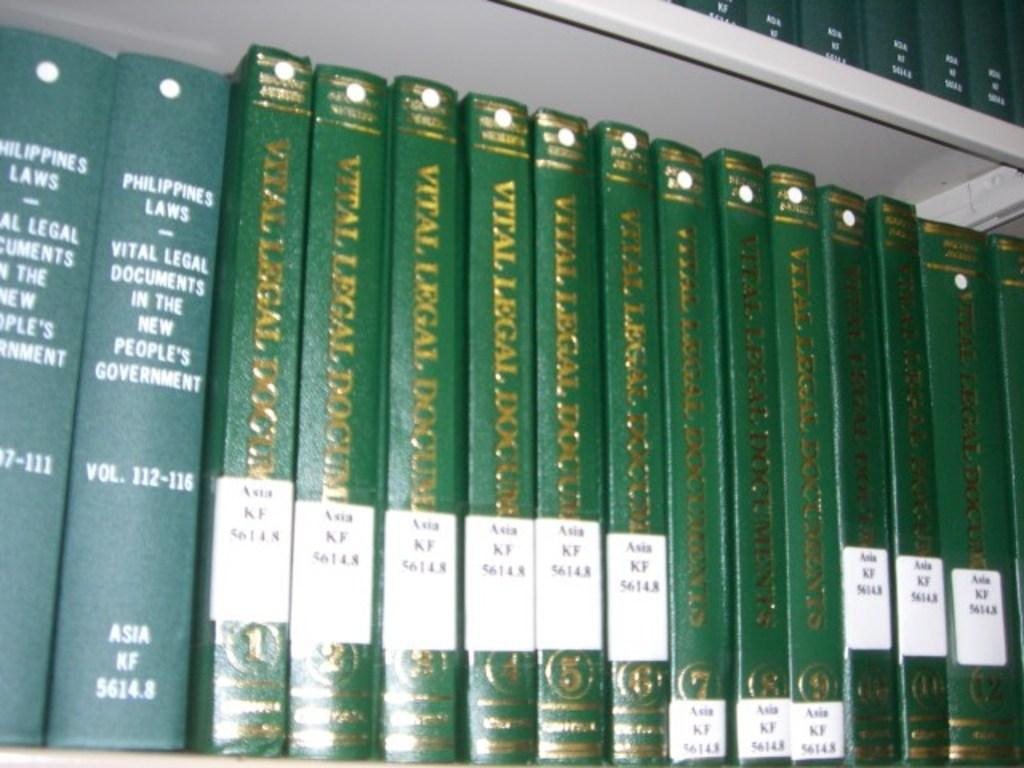<image>
Relay a brief, clear account of the picture shown. A series of green books on a shelf called vital legal documents. 